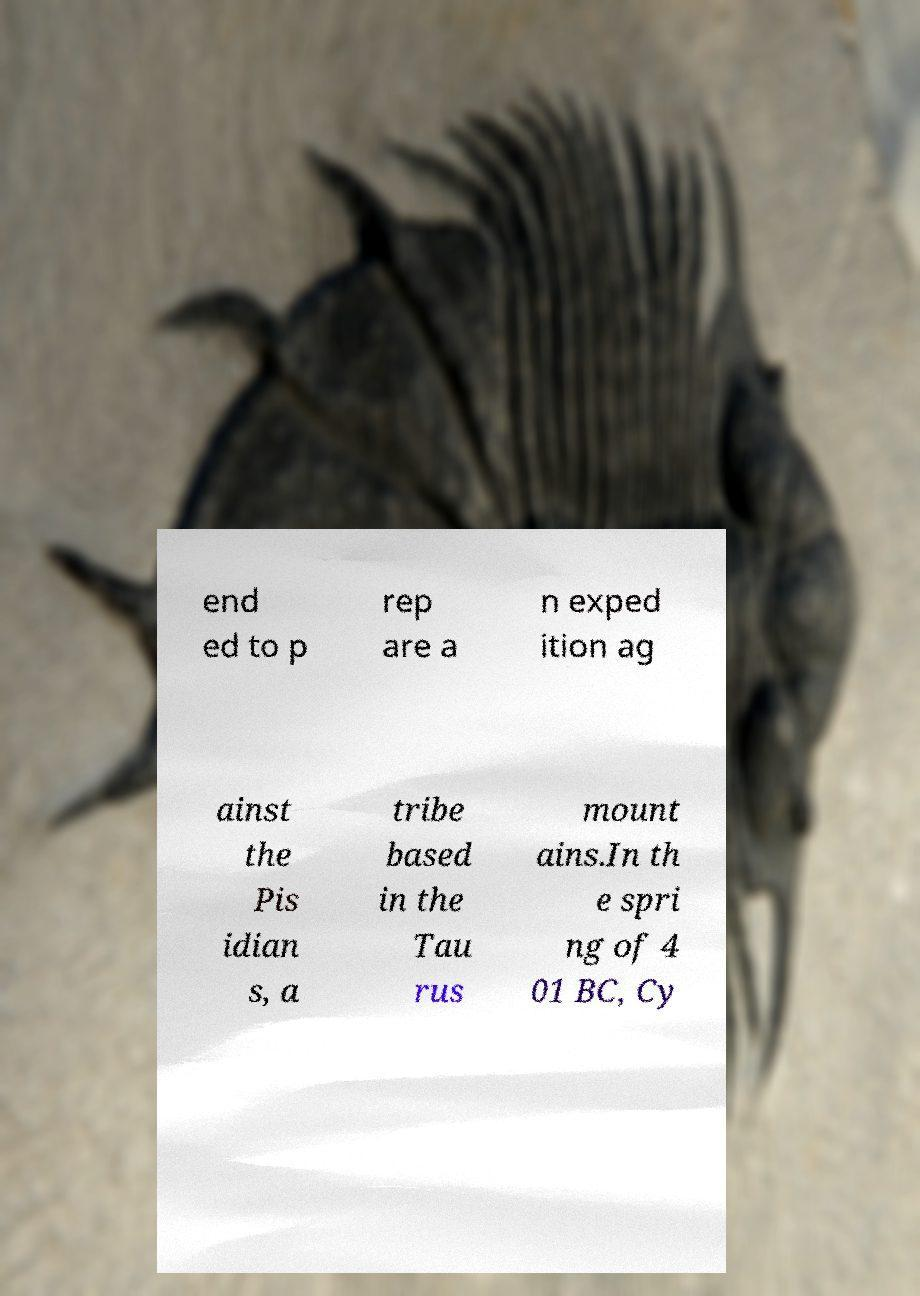I need the written content from this picture converted into text. Can you do that? end ed to p rep are a n exped ition ag ainst the Pis idian s, a tribe based in the Tau rus mount ains.In th e spri ng of 4 01 BC, Cy 